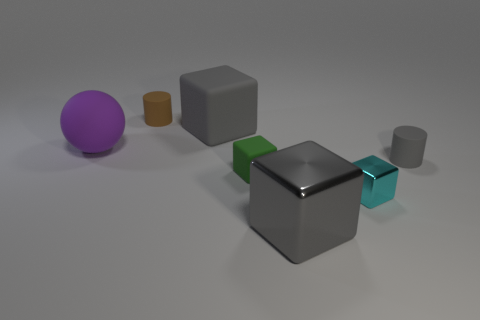Do the big matte block and the big shiny thing have the same color?
Offer a terse response. Yes. What is the color of the cube that is behind the tiny shiny object and in front of the purple rubber sphere?
Keep it short and to the point. Green. What number of things are rubber objects that are right of the big gray shiny block or tiny cyan rubber things?
Give a very brief answer. 1. What is the color of the other object that is the same shape as the brown matte thing?
Your answer should be very brief. Gray. Do the cyan metallic object and the object that is on the right side of the cyan cube have the same shape?
Offer a very short reply. No. What number of things are either big gray blocks in front of the cyan thing or large cubes behind the gray metal object?
Offer a very short reply. 2. Are there fewer big cubes that are right of the small green matte cube than big gray things?
Keep it short and to the point. Yes. Does the small green block have the same material as the big gray thing that is on the right side of the green object?
Offer a terse response. No. What is the material of the small gray cylinder?
Give a very brief answer. Rubber. The gray block that is behind the gray cube that is in front of the matte cylinder on the right side of the small brown object is made of what material?
Your answer should be very brief. Rubber. 